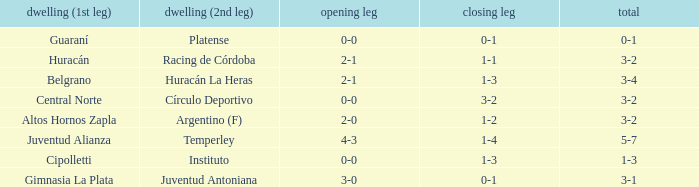What was the aggregate score that had a 1-2 second leg score? 3-2. 